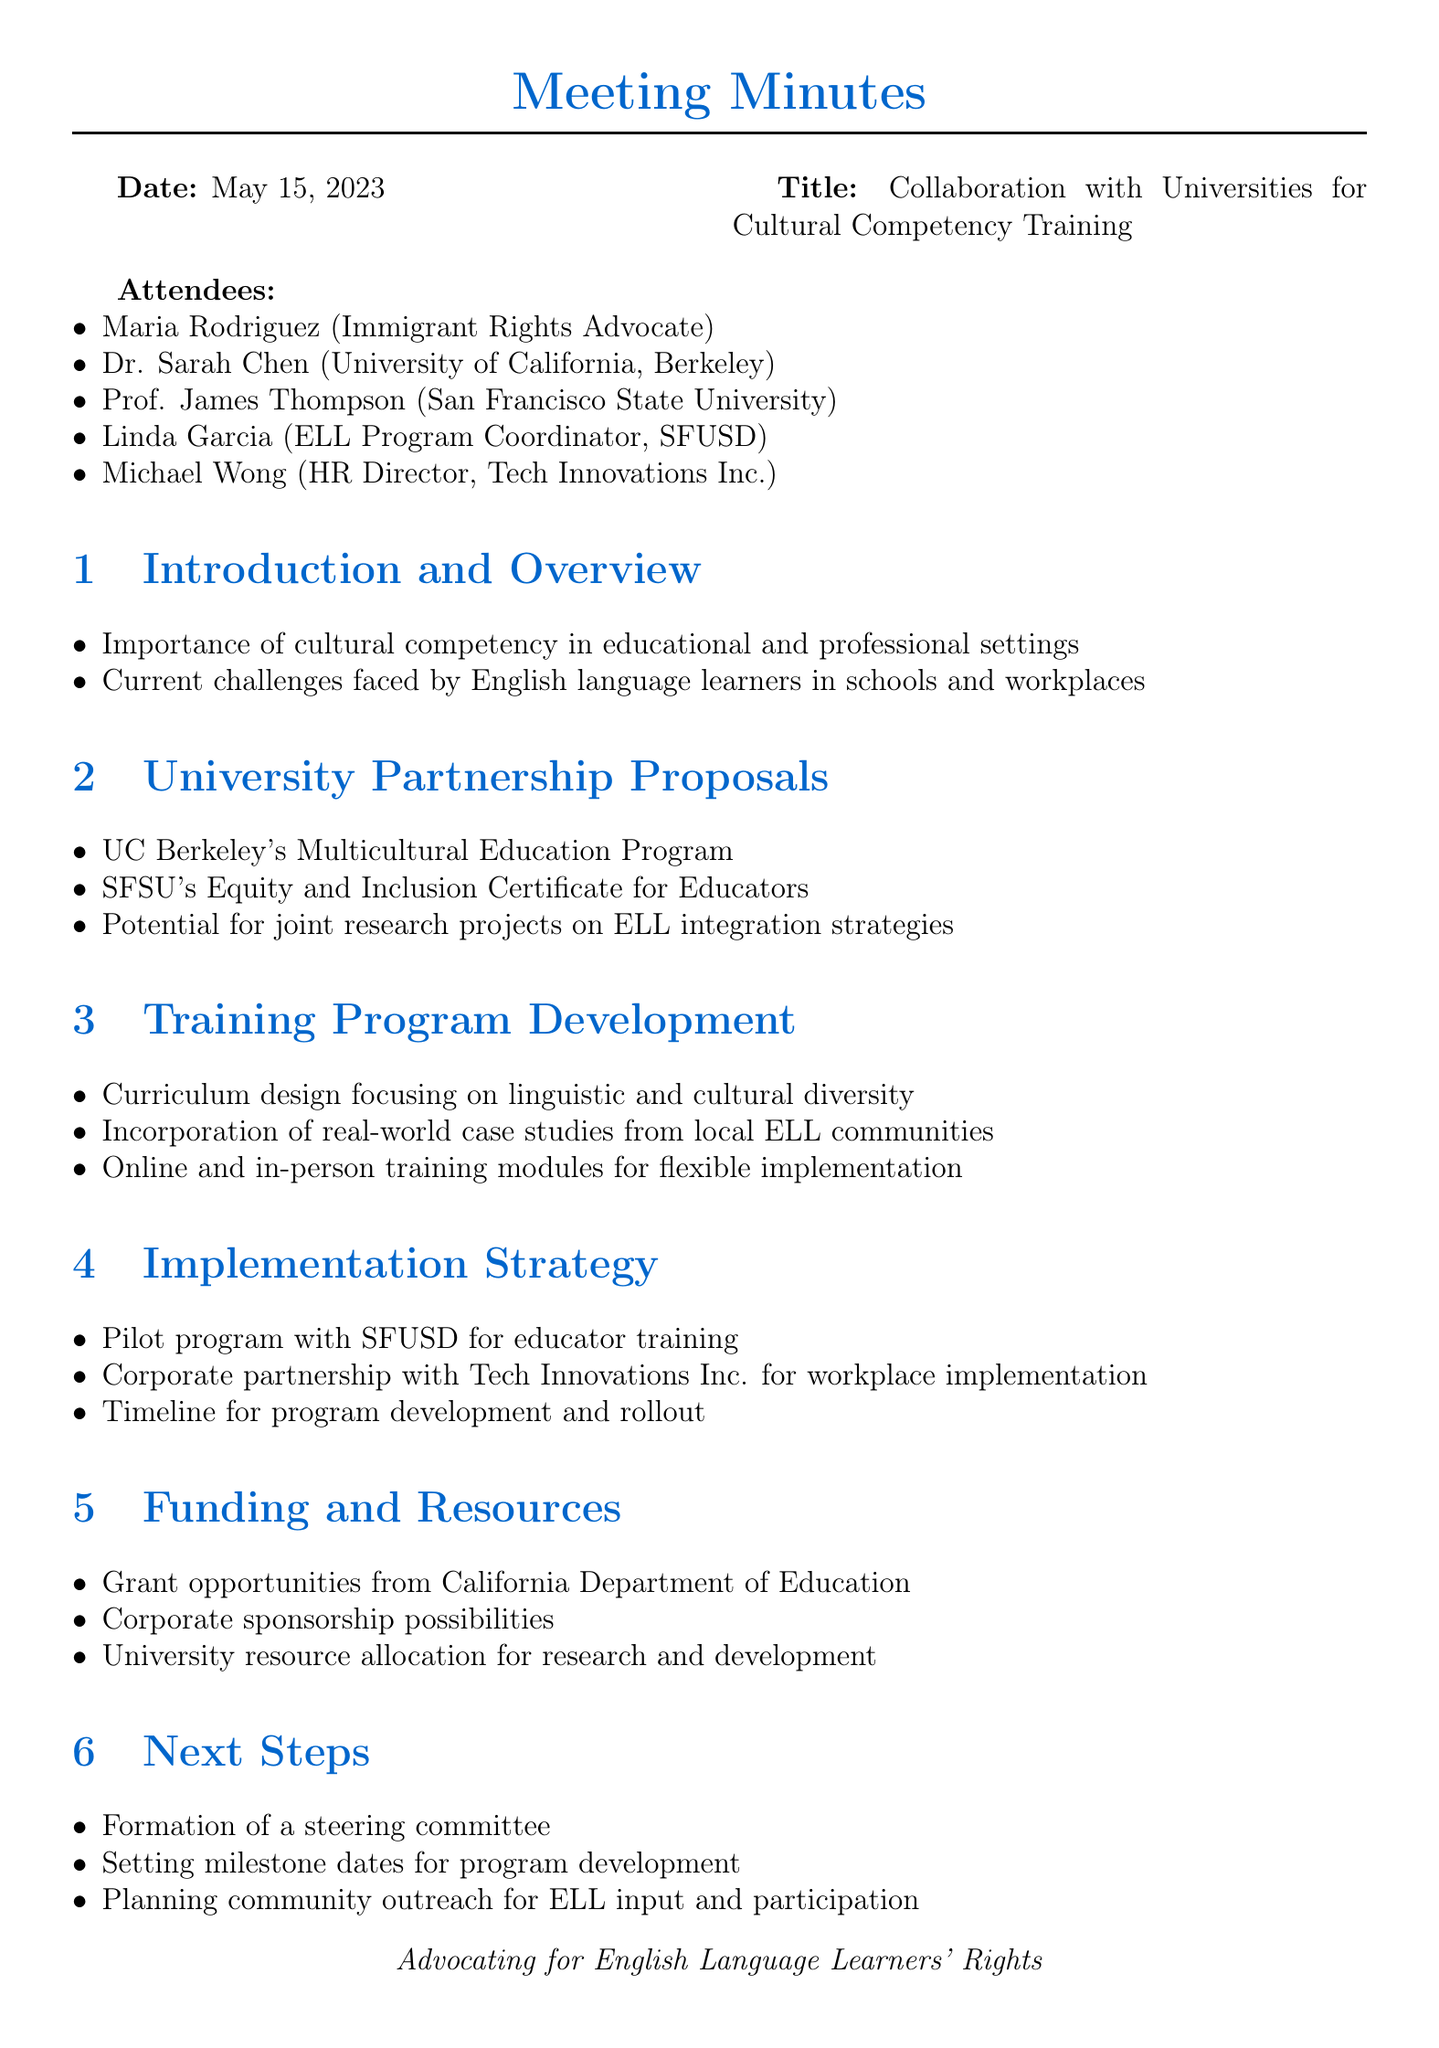What is the date of the meeting? The date of the meeting is listed in the document header.
Answer: May 15, 2023 Who is the HR Director at Tech Innovations Inc.? The attendees' section lists the names and titles of participants.
Answer: Michael Wong What is one of the main topics discussed under University Partnership Proposals? The topics discussed in the meeting are outlined in the agenda items.
Answer: UC Berkeley's Multicultural Education Program What type of program is proposed for ELL training at SFUSD? The Implementation Strategy discusses specific programs to be implemented.
Answer: Pilot program What funding opportunities are mentioned in the document? The Funding and Resources section lists potential sources for support.
Answer: Grant opportunities from California Department of Education How many attendees were present at the meeting? The total number of attendees is derived from the list in the document.
Answer: Five What is one step mentioned for community outreach? The Next Steps section outlines plans for engaging the community.
Answer: Planning community outreach for ELL input and participation What is the main focus of the Training Program Development? The Training Program Development section discusses key aspects of the training program.
Answer: Curriculum design focusing on linguistic and cultural diversity 